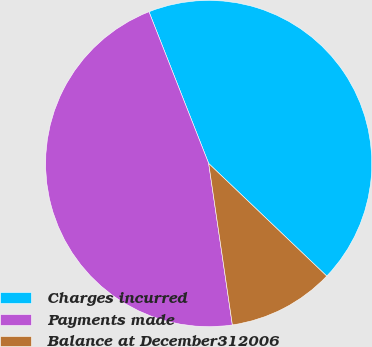Convert chart to OTSL. <chart><loc_0><loc_0><loc_500><loc_500><pie_chart><fcel>Charges incurred<fcel>Payments made<fcel>Balance at December312006<nl><fcel>43.09%<fcel>46.35%<fcel>10.56%<nl></chart> 